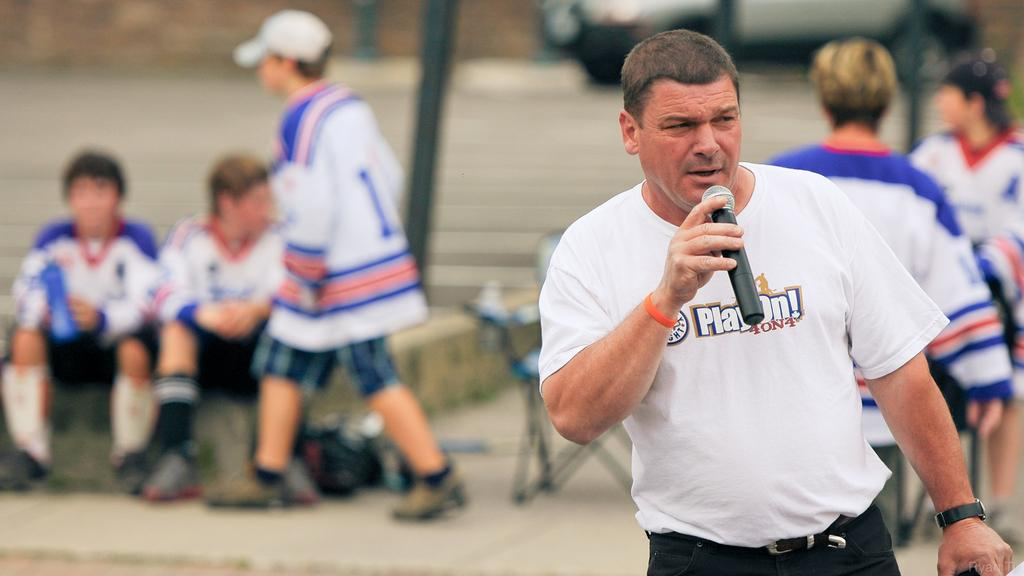What is the person in the image holding? The person in the image is holding a mic. Can you describe the background of the image? There are people and a vehicle on the road in the background of the image. What else can be seen in the background? There is a rod in the background of the image. How many fish can be seen swimming in the image? There are no fish present in the image. What type of comb is being used by the person holding the mic? There is no comb visible in the image, as the person is holding a mic and not a comb. 